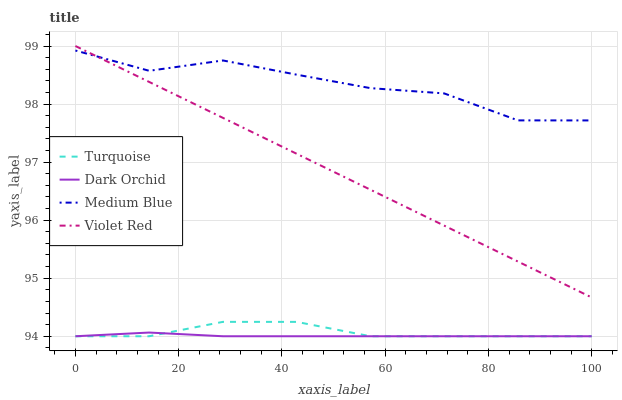Does Dark Orchid have the minimum area under the curve?
Answer yes or no. Yes. Does Medium Blue have the maximum area under the curve?
Answer yes or no. Yes. Does Violet Red have the minimum area under the curve?
Answer yes or no. No. Does Violet Red have the maximum area under the curve?
Answer yes or no. No. Is Violet Red the smoothest?
Answer yes or no. Yes. Is Medium Blue the roughest?
Answer yes or no. Yes. Is Medium Blue the smoothest?
Answer yes or no. No. Is Violet Red the roughest?
Answer yes or no. No. Does Violet Red have the lowest value?
Answer yes or no. No. Does Violet Red have the highest value?
Answer yes or no. Yes. Does Medium Blue have the highest value?
Answer yes or no. No. Is Dark Orchid less than Medium Blue?
Answer yes or no. Yes. Is Medium Blue greater than Turquoise?
Answer yes or no. Yes. Does Medium Blue intersect Violet Red?
Answer yes or no. Yes. Is Medium Blue less than Violet Red?
Answer yes or no. No. Is Medium Blue greater than Violet Red?
Answer yes or no. No. Does Dark Orchid intersect Medium Blue?
Answer yes or no. No. 